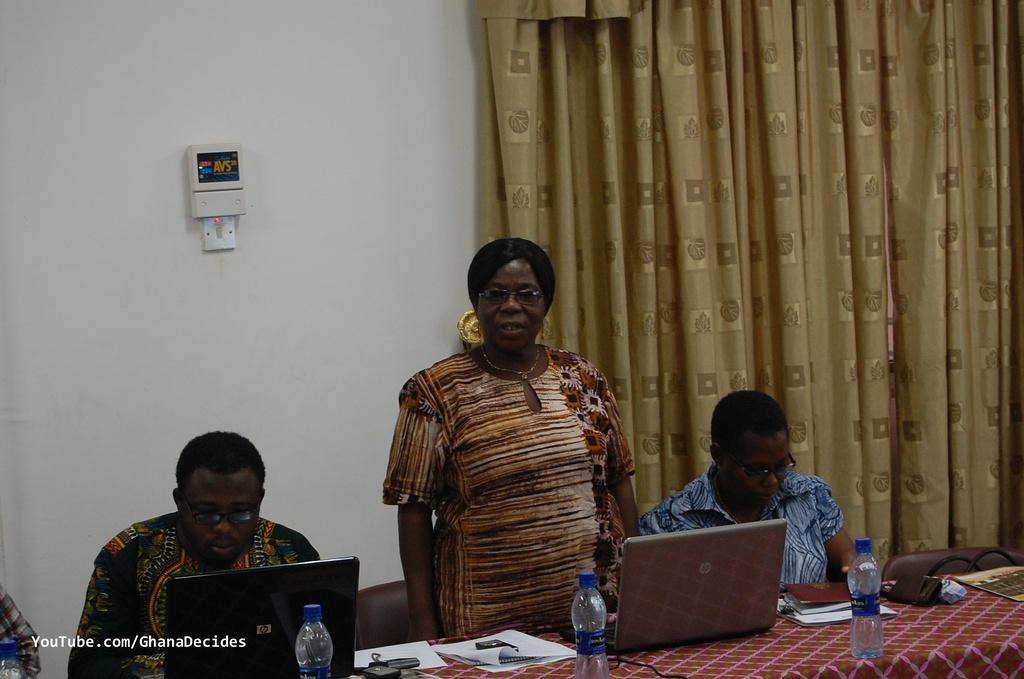Can you describe this image briefly? In this picture we can see two persons sitting on the chairs. This is table. On the table there are bottles, laptops, and papers. Here we can see a woman who is standing and she has spectacles. On the background there is a wall and this is curtain. 